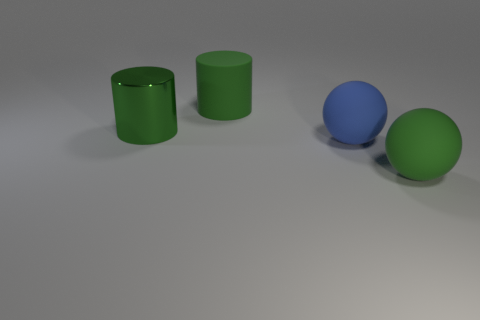Is there a tiny gray matte object that has the same shape as the big metallic thing?
Your answer should be compact. No. What number of green objects are the same material as the large blue sphere?
Offer a terse response. 2. Do the large object to the right of the blue sphere and the blue ball have the same material?
Offer a very short reply. Yes. Is the number of green matte things that are on the right side of the green metal cylinder greater than the number of large green rubber things in front of the large blue object?
Keep it short and to the point. Yes. There is a green sphere that is the same size as the blue thing; what is it made of?
Keep it short and to the point. Rubber. What number of other things are there of the same material as the large blue ball
Provide a short and direct response. 2. There is a big green matte thing behind the large green metallic object; is it the same shape as the large metal thing behind the green sphere?
Offer a terse response. Yes. How many other objects are the same color as the large rubber cylinder?
Offer a terse response. 2. Does the thing that is in front of the big blue thing have the same material as the thing behind the big green metal object?
Offer a very short reply. Yes. Are there an equal number of large blue matte things that are behind the green metal cylinder and cylinders in front of the green rubber cylinder?
Your answer should be very brief. No. 